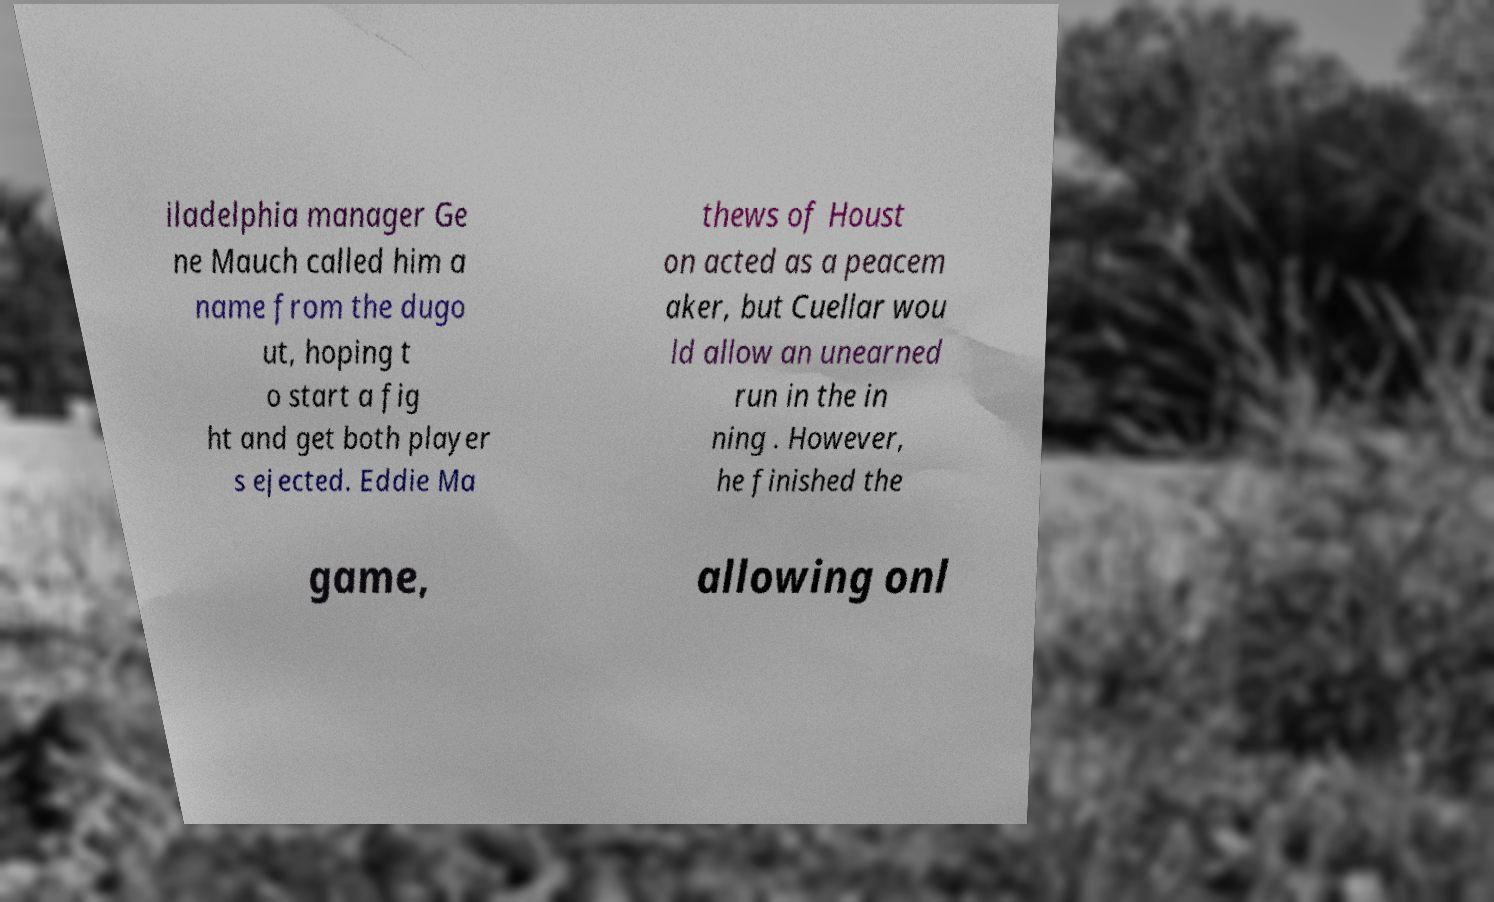Please read and relay the text visible in this image. What does it say? iladelphia manager Ge ne Mauch called him a name from the dugo ut, hoping t o start a fig ht and get both player s ejected. Eddie Ma thews of Houst on acted as a peacem aker, but Cuellar wou ld allow an unearned run in the in ning . However, he finished the game, allowing onl 